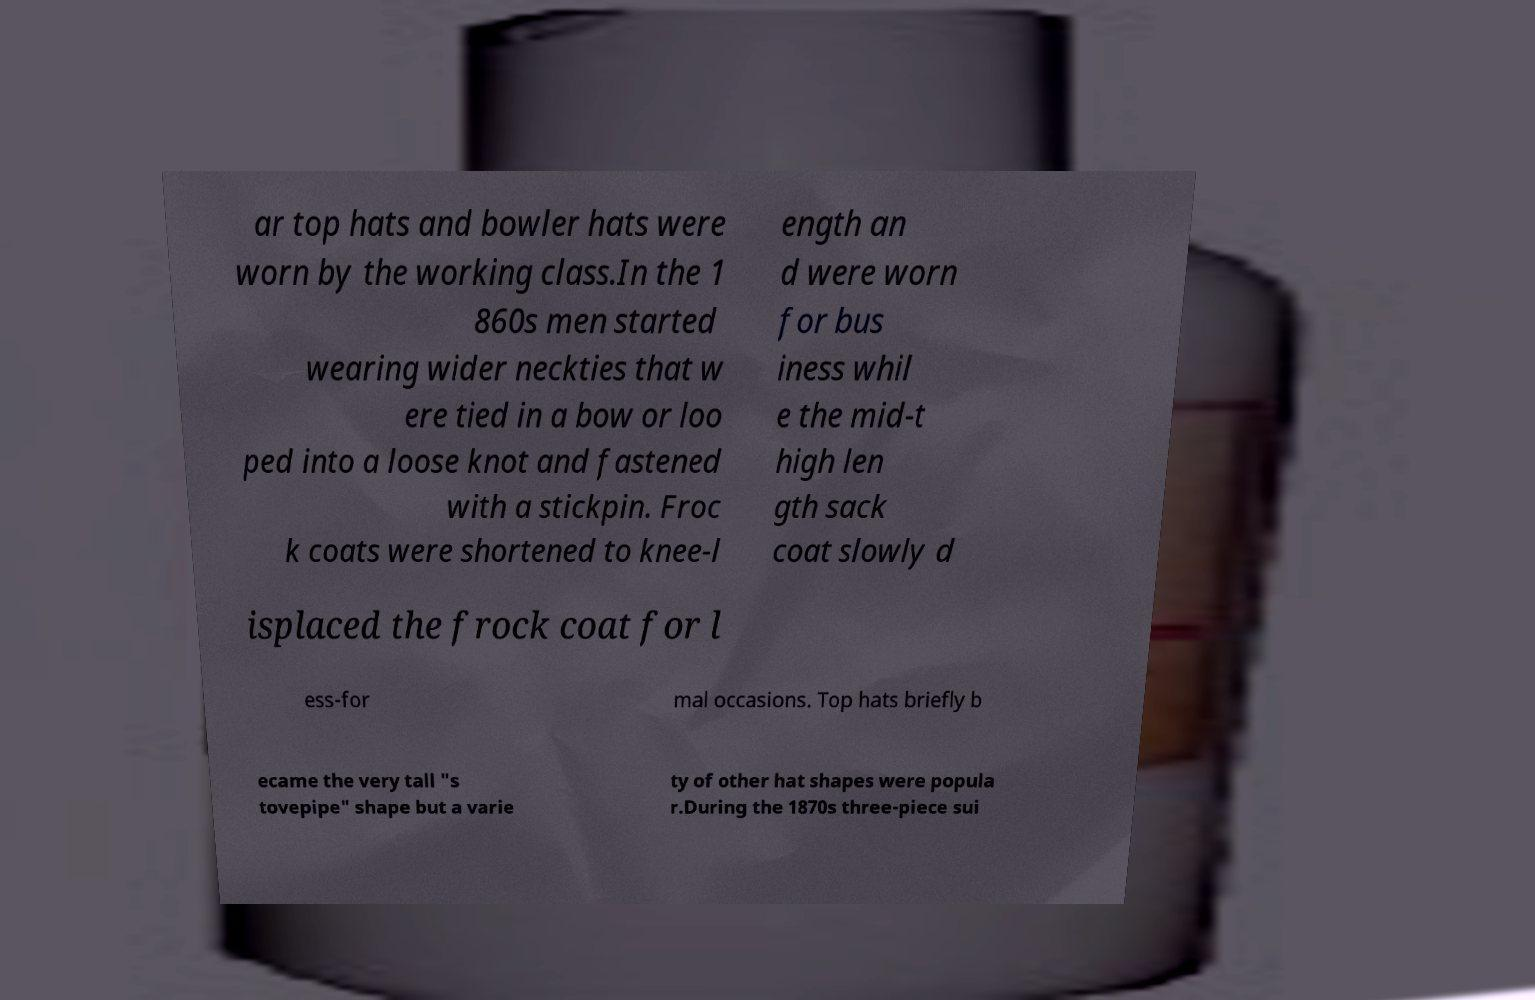For documentation purposes, I need the text within this image transcribed. Could you provide that? ar top hats and bowler hats were worn by the working class.In the 1 860s men started wearing wider neckties that w ere tied in a bow or loo ped into a loose knot and fastened with a stickpin. Froc k coats were shortened to knee-l ength an d were worn for bus iness whil e the mid-t high len gth sack coat slowly d isplaced the frock coat for l ess-for mal occasions. Top hats briefly b ecame the very tall "s tovepipe" shape but a varie ty of other hat shapes were popula r.During the 1870s three-piece sui 